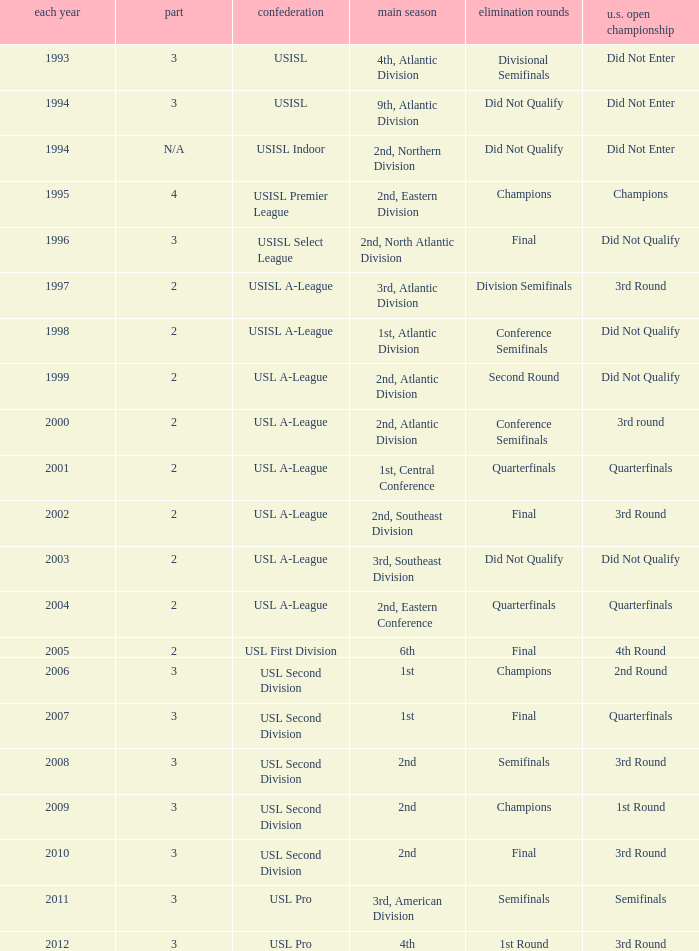What are all the playoffs for u.s. open cup in 1st round Champions. 